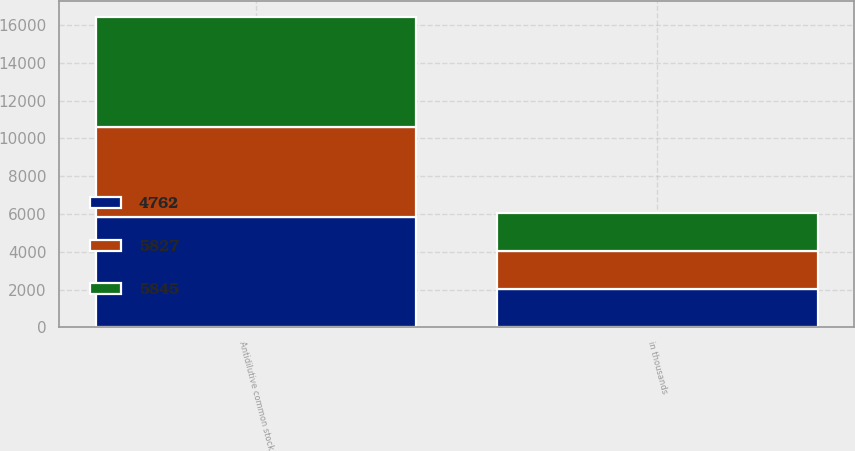Convert chart. <chart><loc_0><loc_0><loc_500><loc_500><stacked_bar_chart><ecel><fcel>in thousands<fcel>Antidilutive common stock<nl><fcel>5827<fcel>2012<fcel>4762<nl><fcel>5845<fcel>2011<fcel>5845<nl><fcel>4762<fcel>2010<fcel>5827<nl></chart> 